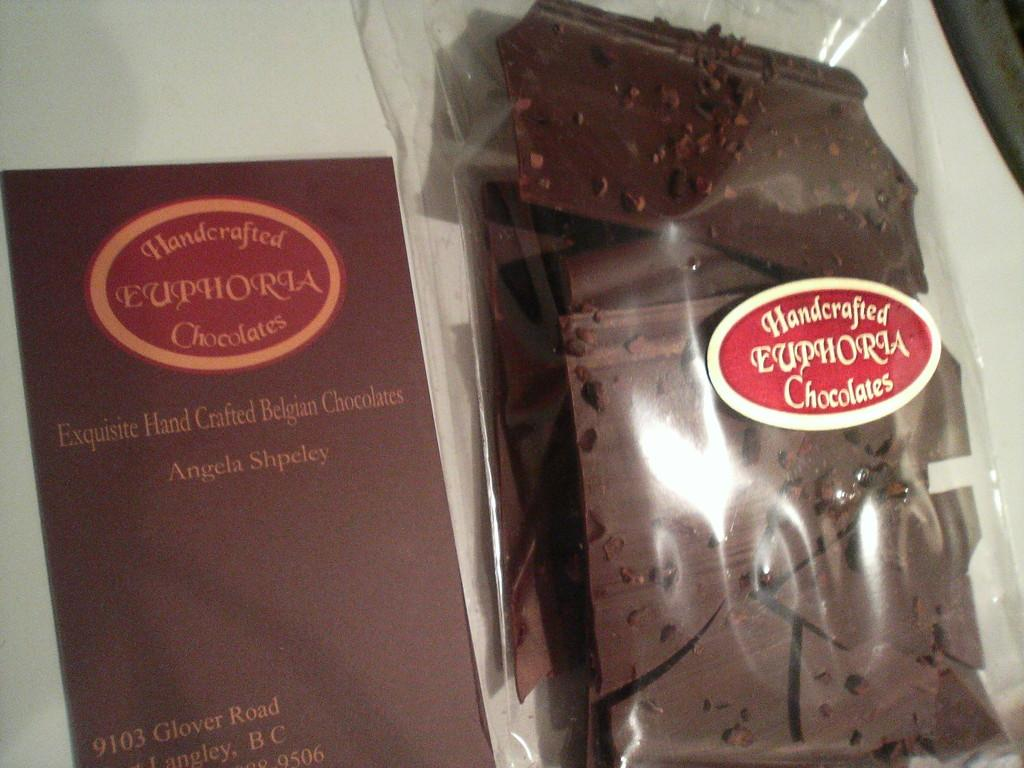Provide a one-sentence caption for the provided image. Handcrafted chocolates are in a bag which is sitting in a box. 